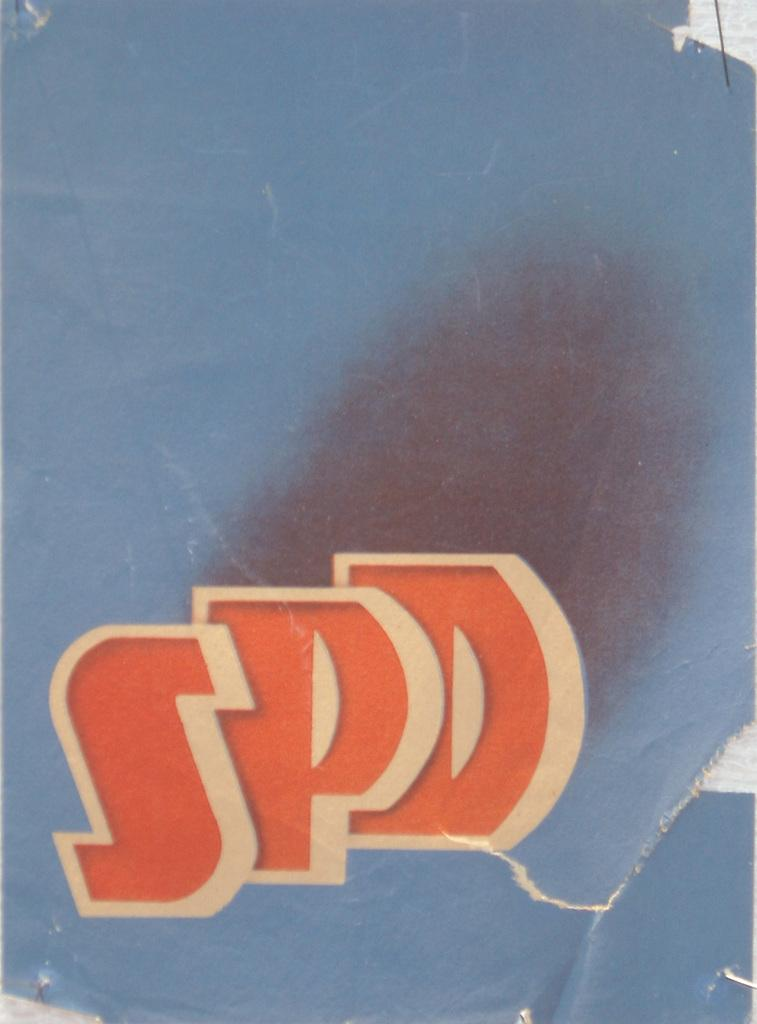<image>
Share a concise interpretation of the image provided. A blue poster with the letters SPD  in orange color. 